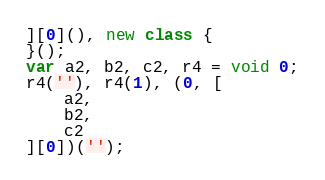Convert code to text. <code><loc_0><loc_0><loc_500><loc_500><_JavaScript_>][0](), new class {
}();
var a2, b2, c2, r4 = void 0;
r4(''), r4(1), (0, [
    a2,
    b2,
    c2
][0])('');
</code> 